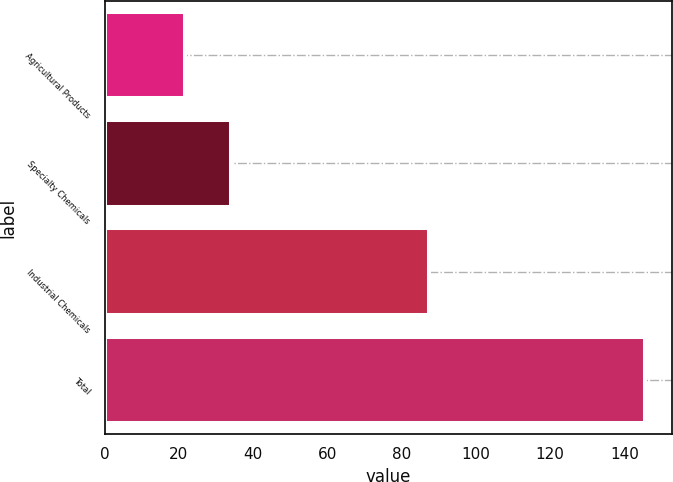Convert chart to OTSL. <chart><loc_0><loc_0><loc_500><loc_500><bar_chart><fcel>Agricultural Products<fcel>Specialty Chemicals<fcel>Industrial Chemicals<fcel>Total<nl><fcel>21.6<fcel>34<fcel>87.3<fcel>145.6<nl></chart> 